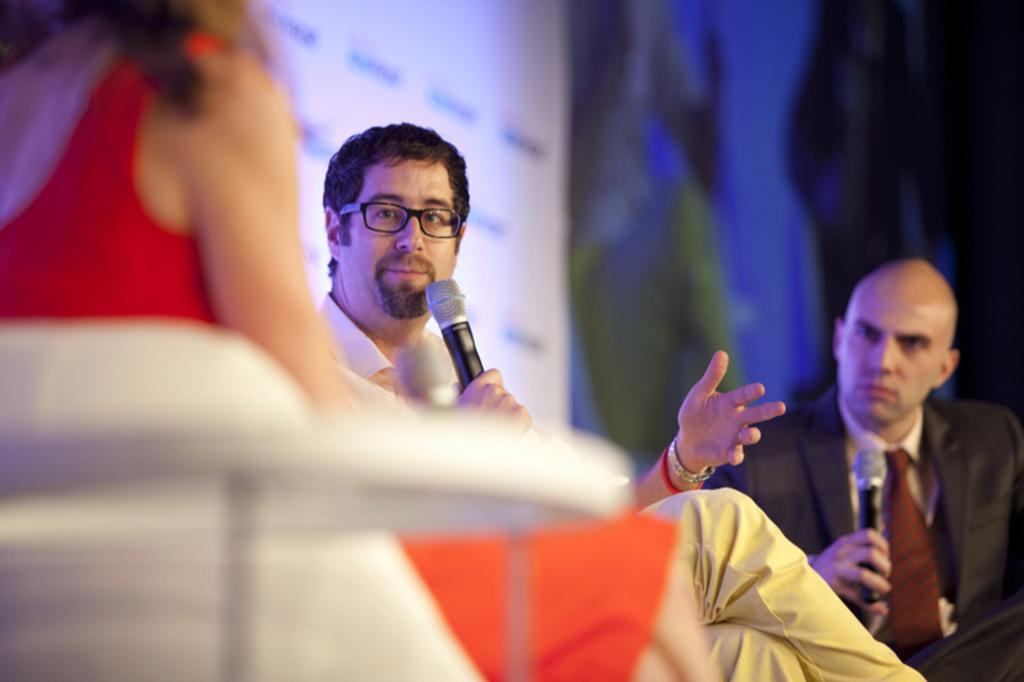What is the lady doing in the image? The lady is sitting on the left side of the image. Who else is present in the image? There are two men in the foreground. What are the men holding in their hands? The men are holding microphones in their hands. Can you describe the background of the image? The background of the image is blurred. Is there a boat visible in the background of the image? No, there is no boat present in the image. What type of paper can be seen on the table in the image? There is no table or paper visible in the image. 